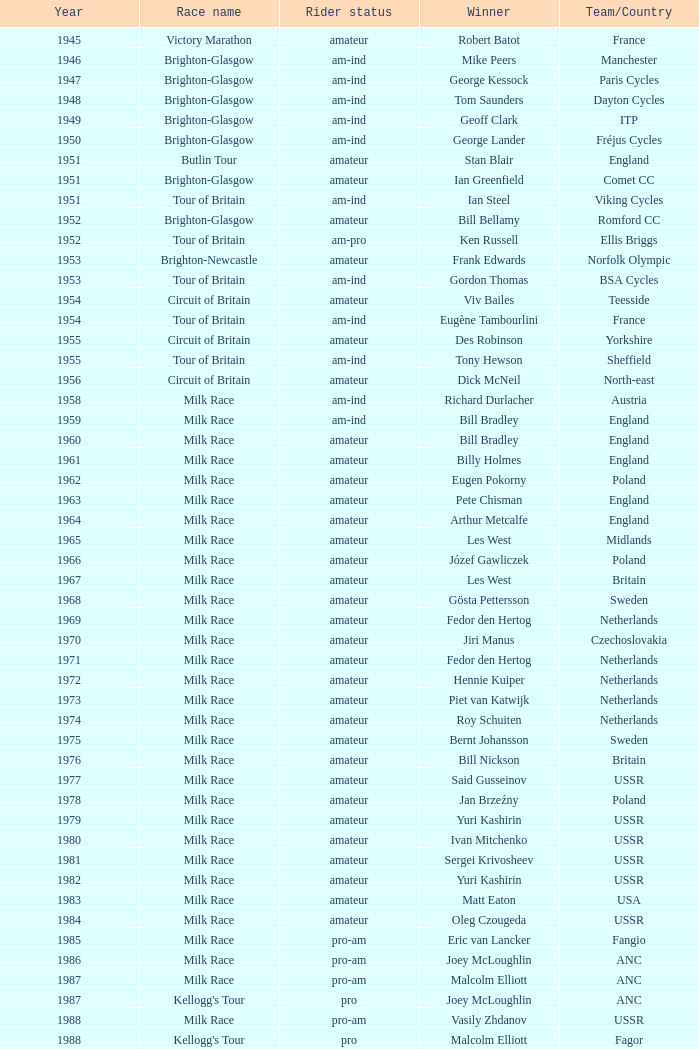What is the latest year when Phil Anderson won? 1993.0. 